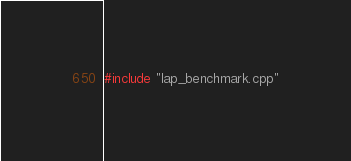<code> <loc_0><loc_0><loc_500><loc_500><_Cuda_>#include "lap_benchmark.cpp"
</code> 